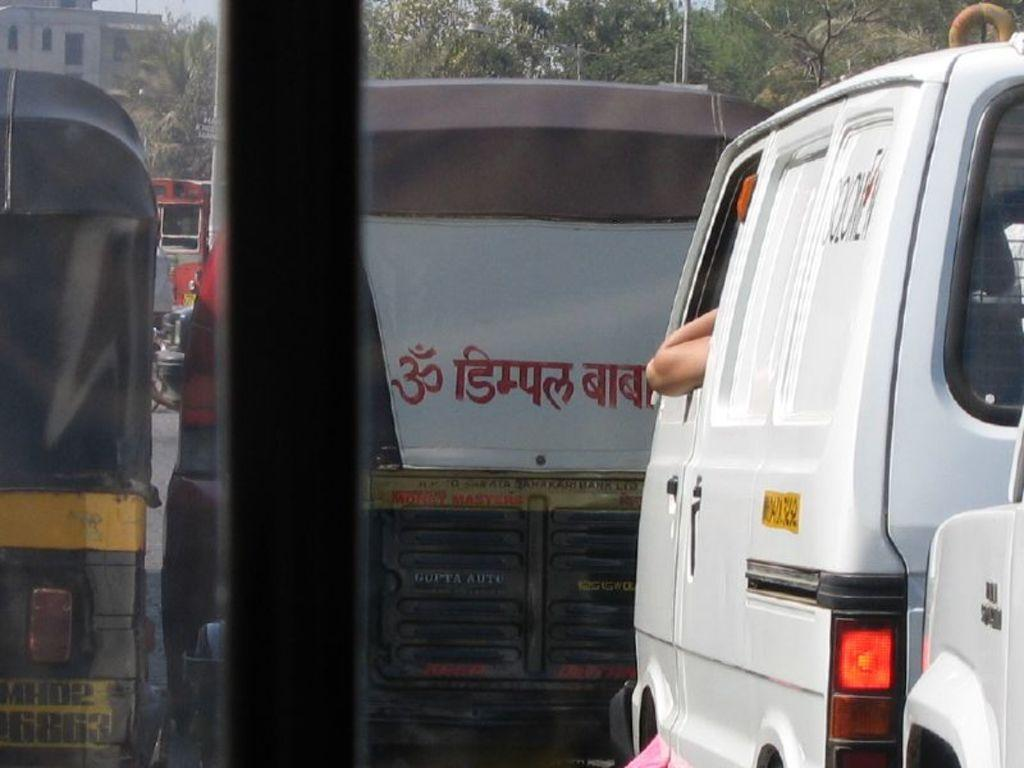What can be seen on the road in the image? There is a group of vehicles on the road in the image. What structures are visible in the image besides the vehicles? There are poles and a building with windows visible in the image. What type of vegetation is present in the image? There is a group of trees in the image. What part of the natural environment is visible in the image? The sky is visible in the image. Can you see your aunt wearing a mask while brushing her teeth in the image? There is no person, including an aunt, present in the image, and therefore no such activity can be observed. 